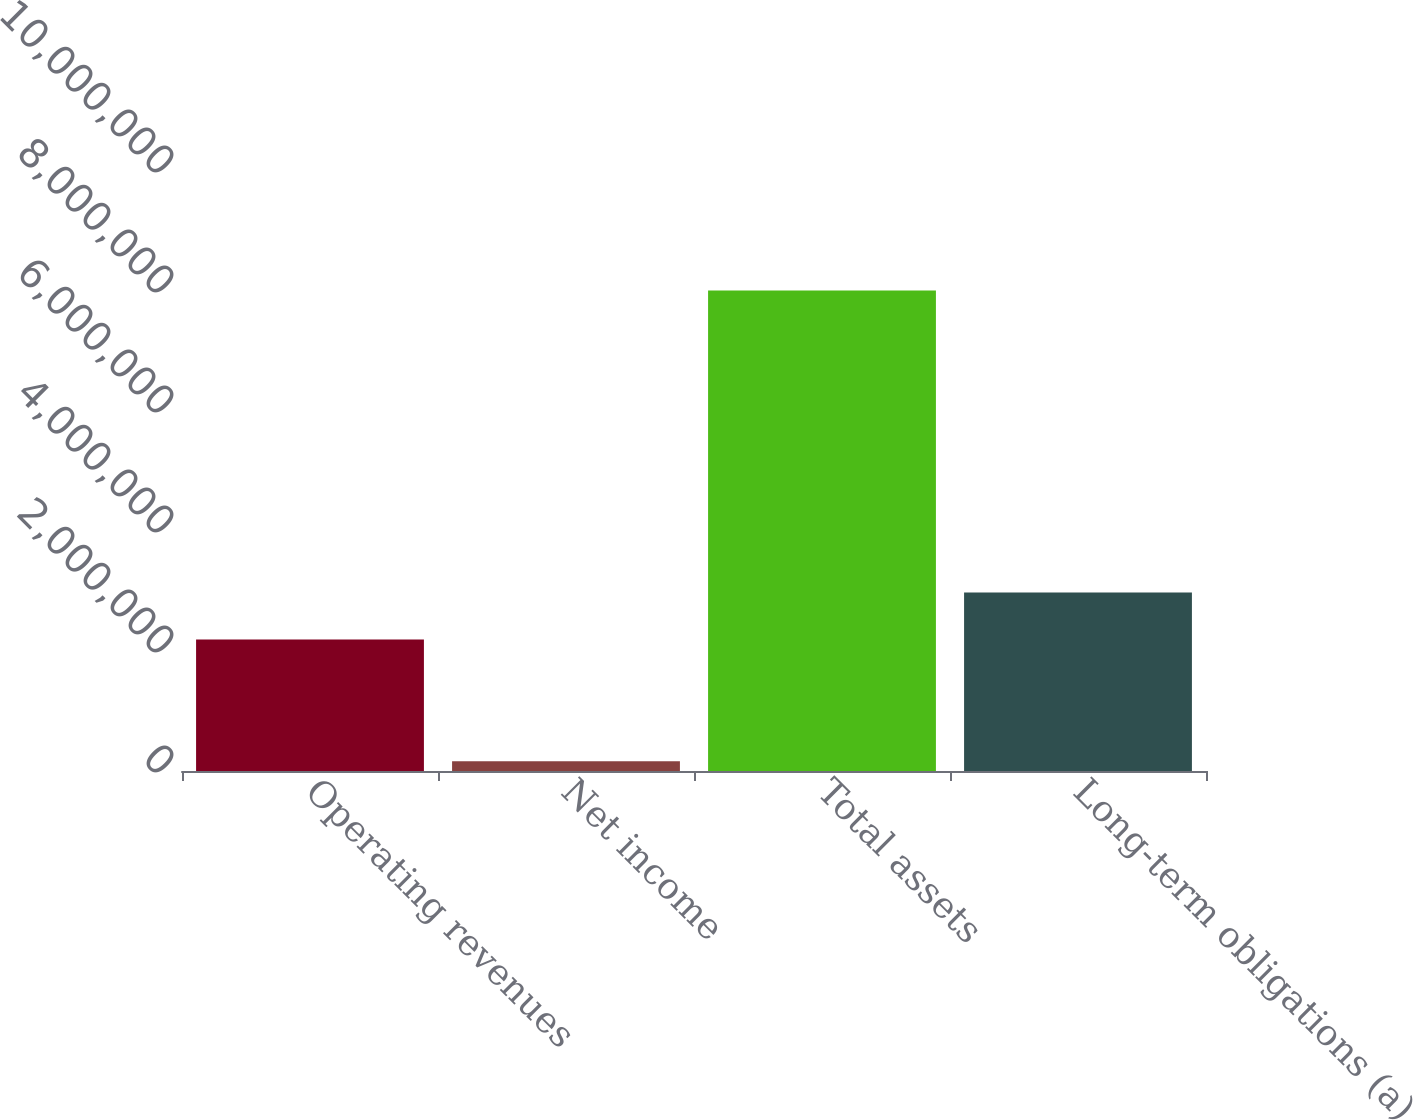<chart> <loc_0><loc_0><loc_500><loc_500><bar_chart><fcel>Operating revenues<fcel>Net income<fcel>Total assets<fcel>Long-term obligations (a)<nl><fcel>2.19016e+06<fcel>161948<fcel>8.00771e+06<fcel>2.97473e+06<nl></chart> 